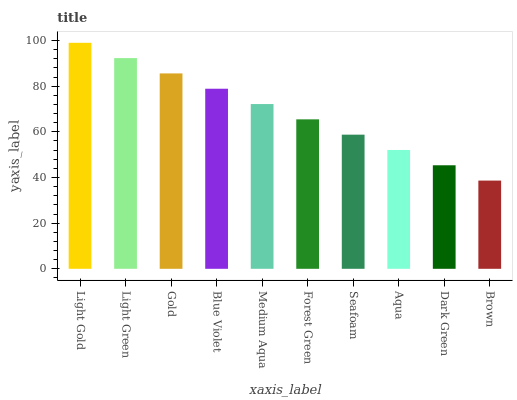Is Brown the minimum?
Answer yes or no. Yes. Is Light Gold the maximum?
Answer yes or no. Yes. Is Light Green the minimum?
Answer yes or no. No. Is Light Green the maximum?
Answer yes or no. No. Is Light Gold greater than Light Green?
Answer yes or no. Yes. Is Light Green less than Light Gold?
Answer yes or no. Yes. Is Light Green greater than Light Gold?
Answer yes or no. No. Is Light Gold less than Light Green?
Answer yes or no. No. Is Medium Aqua the high median?
Answer yes or no. Yes. Is Forest Green the low median?
Answer yes or no. Yes. Is Light Gold the high median?
Answer yes or no. No. Is Light Gold the low median?
Answer yes or no. No. 